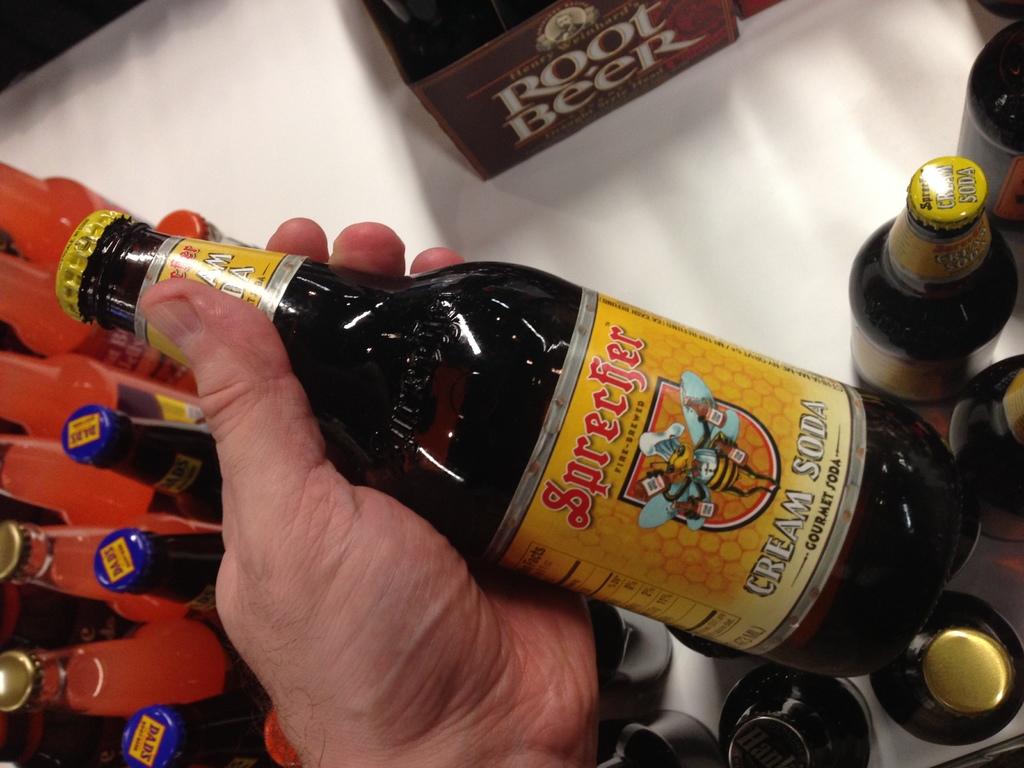What brand of beer?
Make the answer very short. Sprecher. What flavor of soda is on the bottle?
Ensure brevity in your answer.  Cream. 